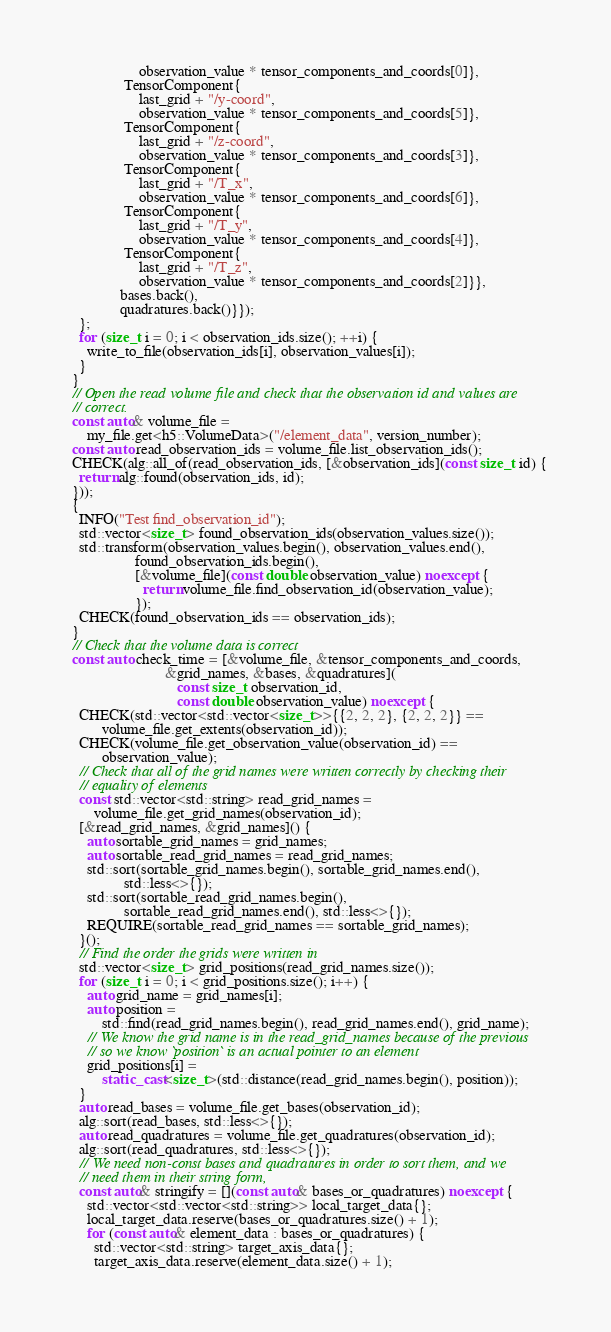Convert code to text. <code><loc_0><loc_0><loc_500><loc_500><_C++_>                    observation_value * tensor_components_and_coords[0]},
                TensorComponent{
                    last_grid + "/y-coord",
                    observation_value * tensor_components_and_coords[5]},
                TensorComponent{
                    last_grid + "/z-coord",
                    observation_value * tensor_components_and_coords[3]},
                TensorComponent{
                    last_grid + "/T_x",
                    observation_value * tensor_components_and_coords[6]},
                TensorComponent{
                    last_grid + "/T_y",
                    observation_value * tensor_components_and_coords[4]},
                TensorComponent{
                    last_grid + "/T_z",
                    observation_value * tensor_components_and_coords[2]}},
               bases.back(),
               quadratures.back()}});
    };
    for (size_t i = 0; i < observation_ids.size(); ++i) {
      write_to_file(observation_ids[i], observation_values[i]);
    }
  }
  // Open the read volume file and check that the observation id and values are
  // correct.
  const auto& volume_file =
      my_file.get<h5::VolumeData>("/element_data", version_number);
  const auto read_observation_ids = volume_file.list_observation_ids();
  CHECK(alg::all_of(read_observation_ids, [&observation_ids](const size_t id) {
    return alg::found(observation_ids, id);
  }));
  {
    INFO("Test find_observation_id");
    std::vector<size_t> found_observation_ids(observation_values.size());
    std::transform(observation_values.begin(), observation_values.end(),
                   found_observation_ids.begin(),
                   [&volume_file](const double observation_value) noexcept {
                     return volume_file.find_observation_id(observation_value);
                   });
    CHECK(found_observation_ids == observation_ids);
  }
  // Check that the volume data is correct
  const auto check_time = [&volume_file, &tensor_components_and_coords,
                           &grid_names, &bases, &quadratures](
                              const size_t observation_id,
                              const double observation_value) noexcept {
    CHECK(std::vector<std::vector<size_t>>{{2, 2, 2}, {2, 2, 2}} ==
          volume_file.get_extents(observation_id));
    CHECK(volume_file.get_observation_value(observation_id) ==
          observation_value);
    // Check that all of the grid names were written correctly by checking their
    // equality of elements
    const std::vector<std::string> read_grid_names =
        volume_file.get_grid_names(observation_id);
    [&read_grid_names, &grid_names]() {
      auto sortable_grid_names = grid_names;
      auto sortable_read_grid_names = read_grid_names;
      std::sort(sortable_grid_names.begin(), sortable_grid_names.end(),
                std::less<>{});
      std::sort(sortable_read_grid_names.begin(),
                sortable_read_grid_names.end(), std::less<>{});
      REQUIRE(sortable_read_grid_names == sortable_grid_names);
    }();
    // Find the order the grids were written in
    std::vector<size_t> grid_positions(read_grid_names.size());
    for (size_t i = 0; i < grid_positions.size(); i++) {
      auto grid_name = grid_names[i];
      auto position =
          std::find(read_grid_names.begin(), read_grid_names.end(), grid_name);
      // We know the grid name is in the read_grid_names because of the previous
      // so we know `position` is an actual pointer to an element
      grid_positions[i] =
          static_cast<size_t>(std::distance(read_grid_names.begin(), position));
    }
    auto read_bases = volume_file.get_bases(observation_id);
    alg::sort(read_bases, std::less<>{});
    auto read_quadratures = volume_file.get_quadratures(observation_id);
    alg::sort(read_quadratures, std::less<>{});
    // We need non-const bases and quadratures in order to sort them, and we
    // need them in their string form,
    const auto& stringify = [](const auto& bases_or_quadratures) noexcept {
      std::vector<std::vector<std::string>> local_target_data{};
      local_target_data.reserve(bases_or_quadratures.size() + 1);
      for (const auto& element_data : bases_or_quadratures) {
        std::vector<std::string> target_axis_data{};
        target_axis_data.reserve(element_data.size() + 1);</code> 